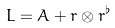<formula> <loc_0><loc_0><loc_500><loc_500>L = A + r \otimes r ^ { \flat }</formula> 